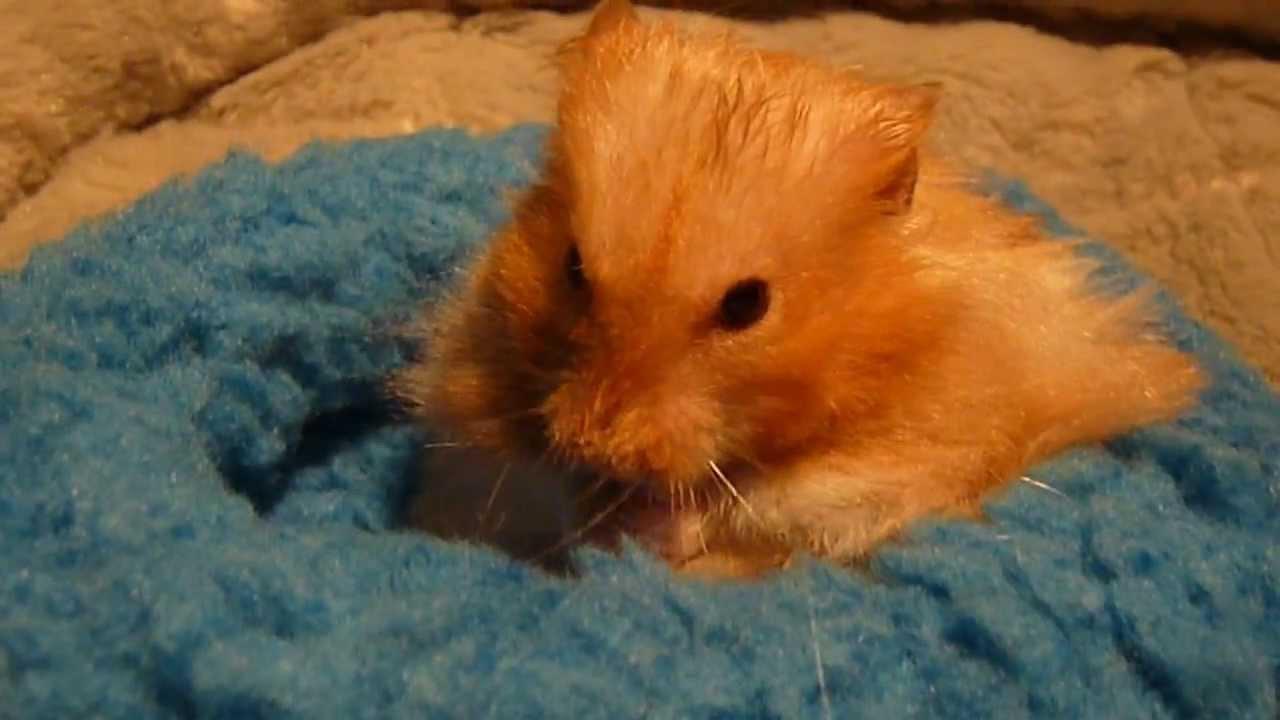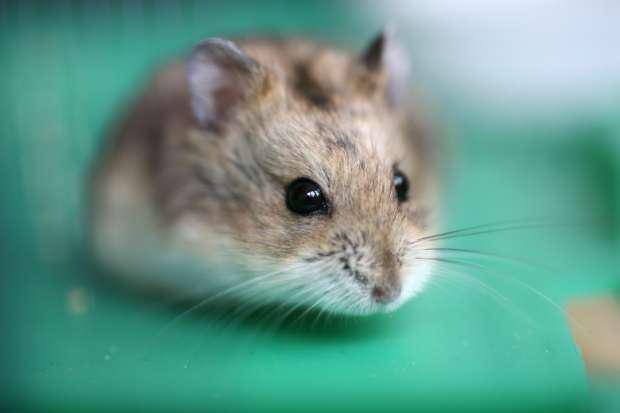The first image is the image on the left, the second image is the image on the right. For the images shown, is this caption "Each image shows at least one hamster on a green surface, and at least one image shows a hamster in a round green plastic object." true? Answer yes or no. No. The first image is the image on the left, the second image is the image on the right. Examine the images to the left and right. Is the description "At least one hamster is swimming in the water." accurate? Answer yes or no. No. 